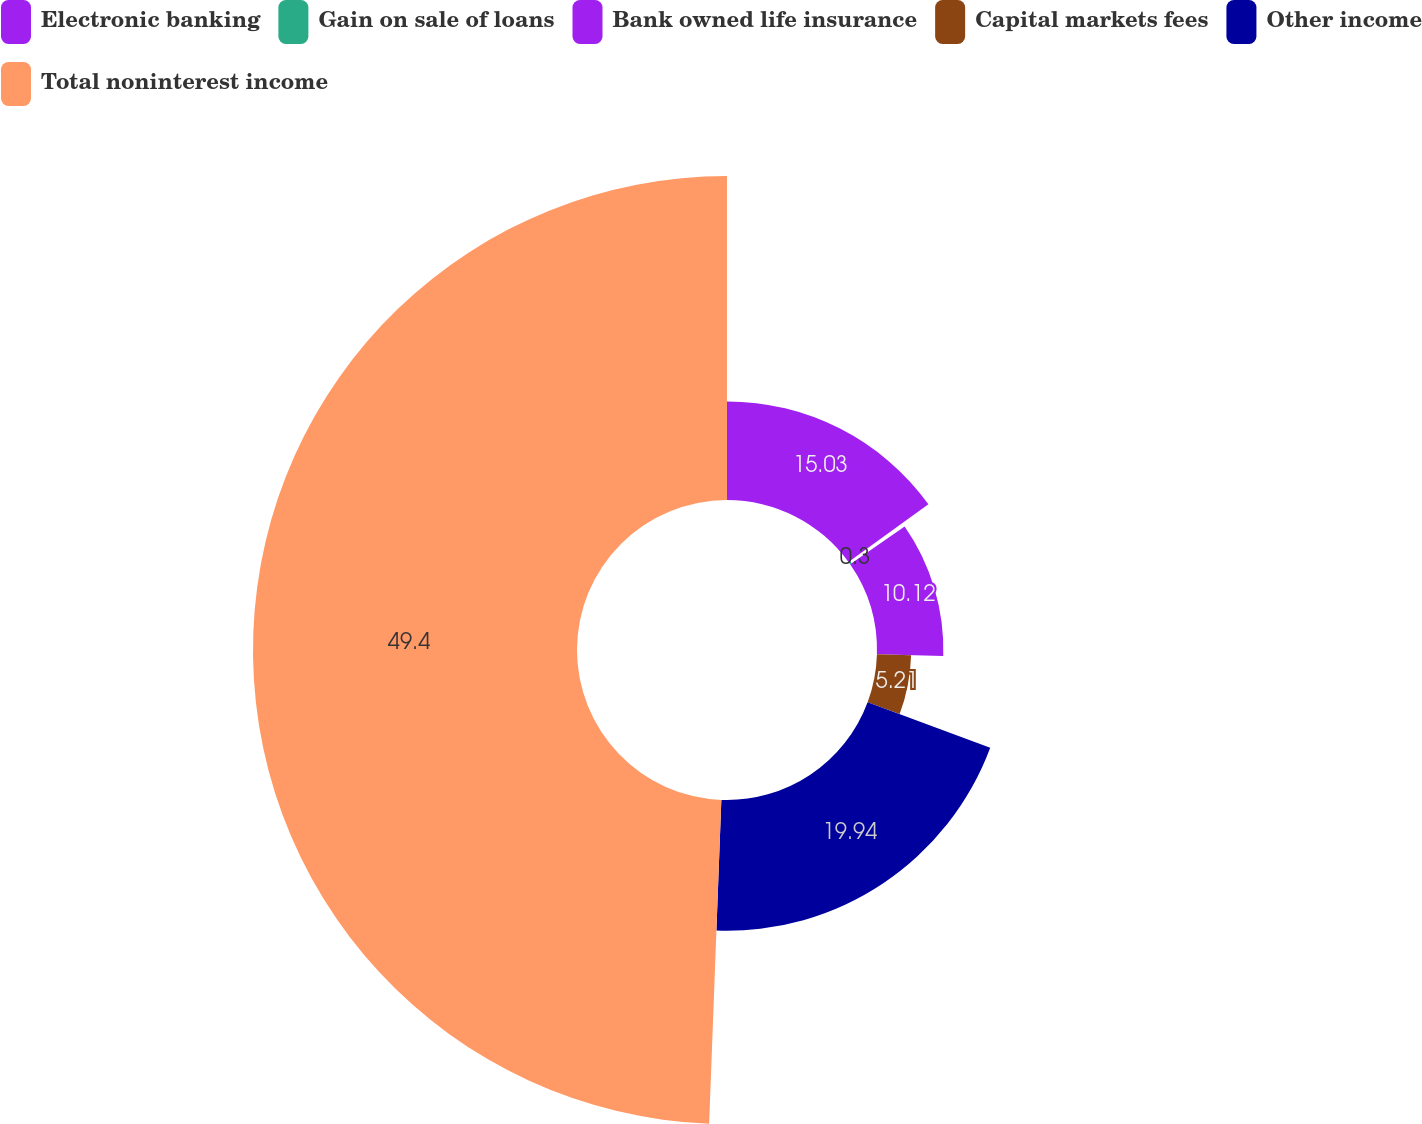Convert chart to OTSL. <chart><loc_0><loc_0><loc_500><loc_500><pie_chart><fcel>Electronic banking<fcel>Gain on sale of loans<fcel>Bank owned life insurance<fcel>Capital markets fees<fcel>Other income<fcel>Total noninterest income<nl><fcel>15.03%<fcel>0.3%<fcel>10.12%<fcel>5.21%<fcel>19.94%<fcel>49.4%<nl></chart> 